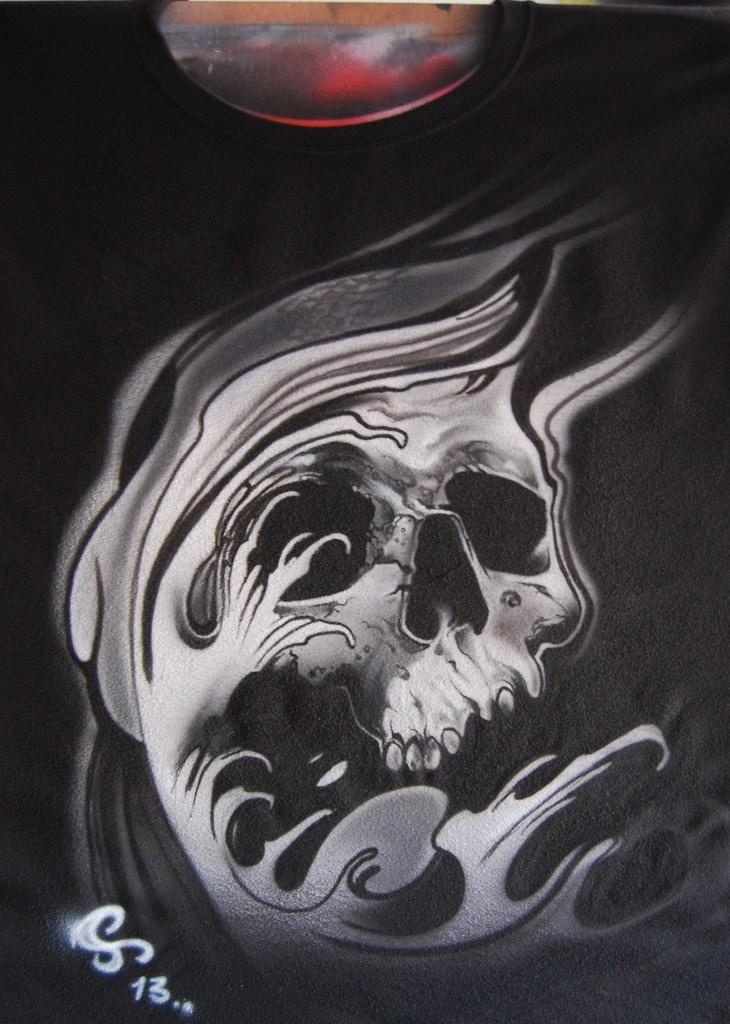What is the main subject of the image? There is a painting in the image. What is depicted in the painting? The painting depicts a skeleton. What type of art can be seen in the fog in the image? There is no fog present in the image, and the painting is the only art visible. 